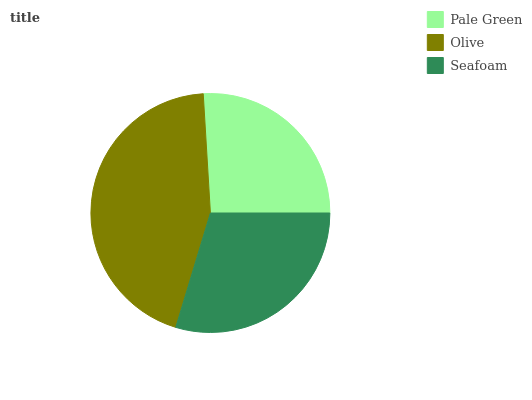Is Pale Green the minimum?
Answer yes or no. Yes. Is Olive the maximum?
Answer yes or no. Yes. Is Seafoam the minimum?
Answer yes or no. No. Is Seafoam the maximum?
Answer yes or no. No. Is Olive greater than Seafoam?
Answer yes or no. Yes. Is Seafoam less than Olive?
Answer yes or no. Yes. Is Seafoam greater than Olive?
Answer yes or no. No. Is Olive less than Seafoam?
Answer yes or no. No. Is Seafoam the high median?
Answer yes or no. Yes. Is Seafoam the low median?
Answer yes or no. Yes. Is Pale Green the high median?
Answer yes or no. No. Is Olive the low median?
Answer yes or no. No. 